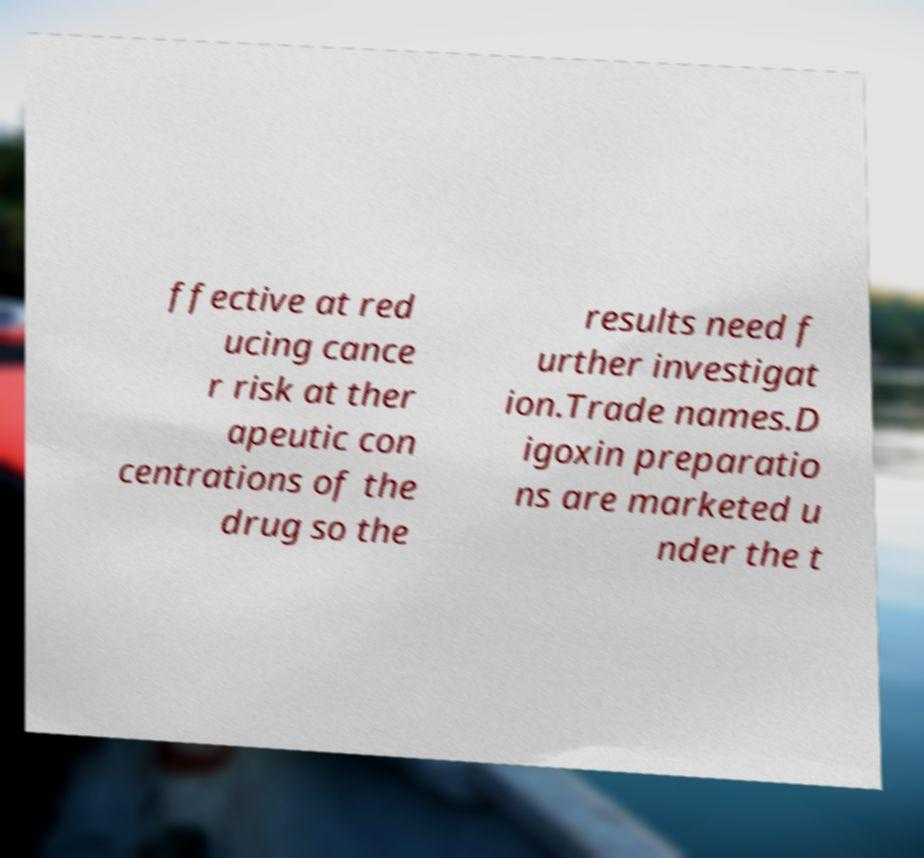There's text embedded in this image that I need extracted. Can you transcribe it verbatim? ffective at red ucing cance r risk at ther apeutic con centrations of the drug so the results need f urther investigat ion.Trade names.D igoxin preparatio ns are marketed u nder the t 